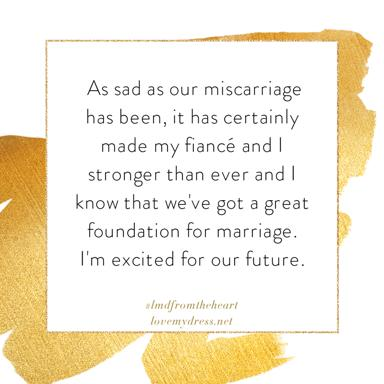How does the choice of colors in the image contribute to its overall message? The use of gold in the image conveys a sense of value and importance. It suggests that despite the sadness of the situation, there is something precious and enduring to be gained. The white background provides a sense of clarity and purity, underscoring the sincerity of the message. 